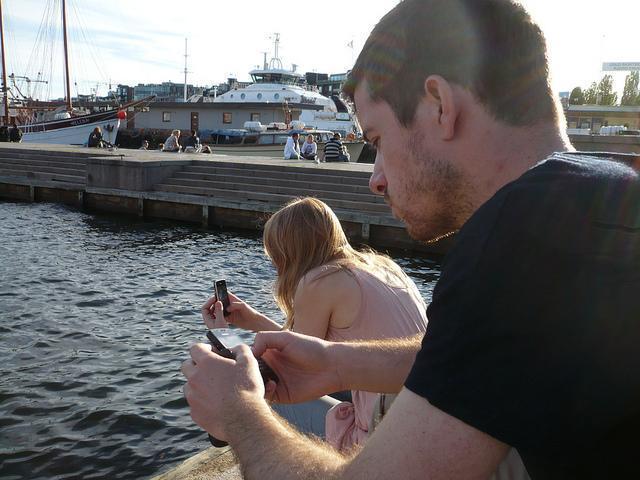If the man threw his phone 2 meters forward where would it land?
Choose the correct response and explain in the format: 'Answer: answer
Rationale: rationale.'
Options: In water, on boat, in grass, on woman. Answer: in water.
Rationale: It would likely throw into water. 